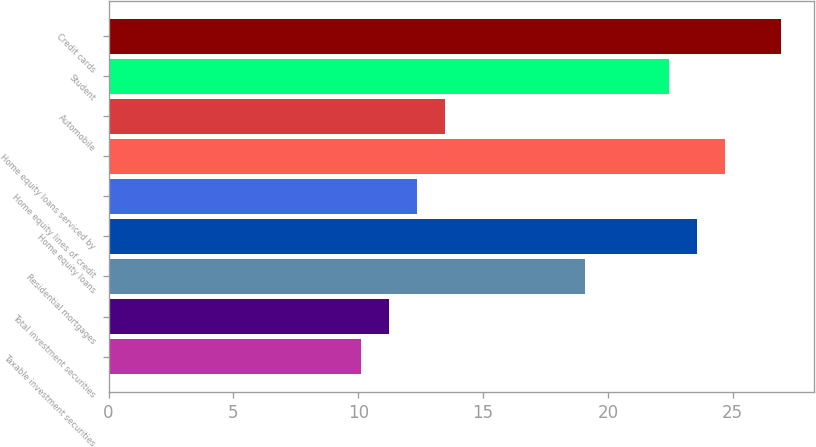Convert chart to OTSL. <chart><loc_0><loc_0><loc_500><loc_500><bar_chart><fcel>Taxable investment securities<fcel>Total investment securities<fcel>Residential mortgages<fcel>Home equity loans<fcel>Home equity lines of credit<fcel>Home equity loans serviced by<fcel>Automobile<fcel>Student<fcel>Credit cards<nl><fcel>10.12<fcel>11.24<fcel>19.08<fcel>23.56<fcel>12.36<fcel>24.68<fcel>13.48<fcel>22.44<fcel>26.92<nl></chart> 